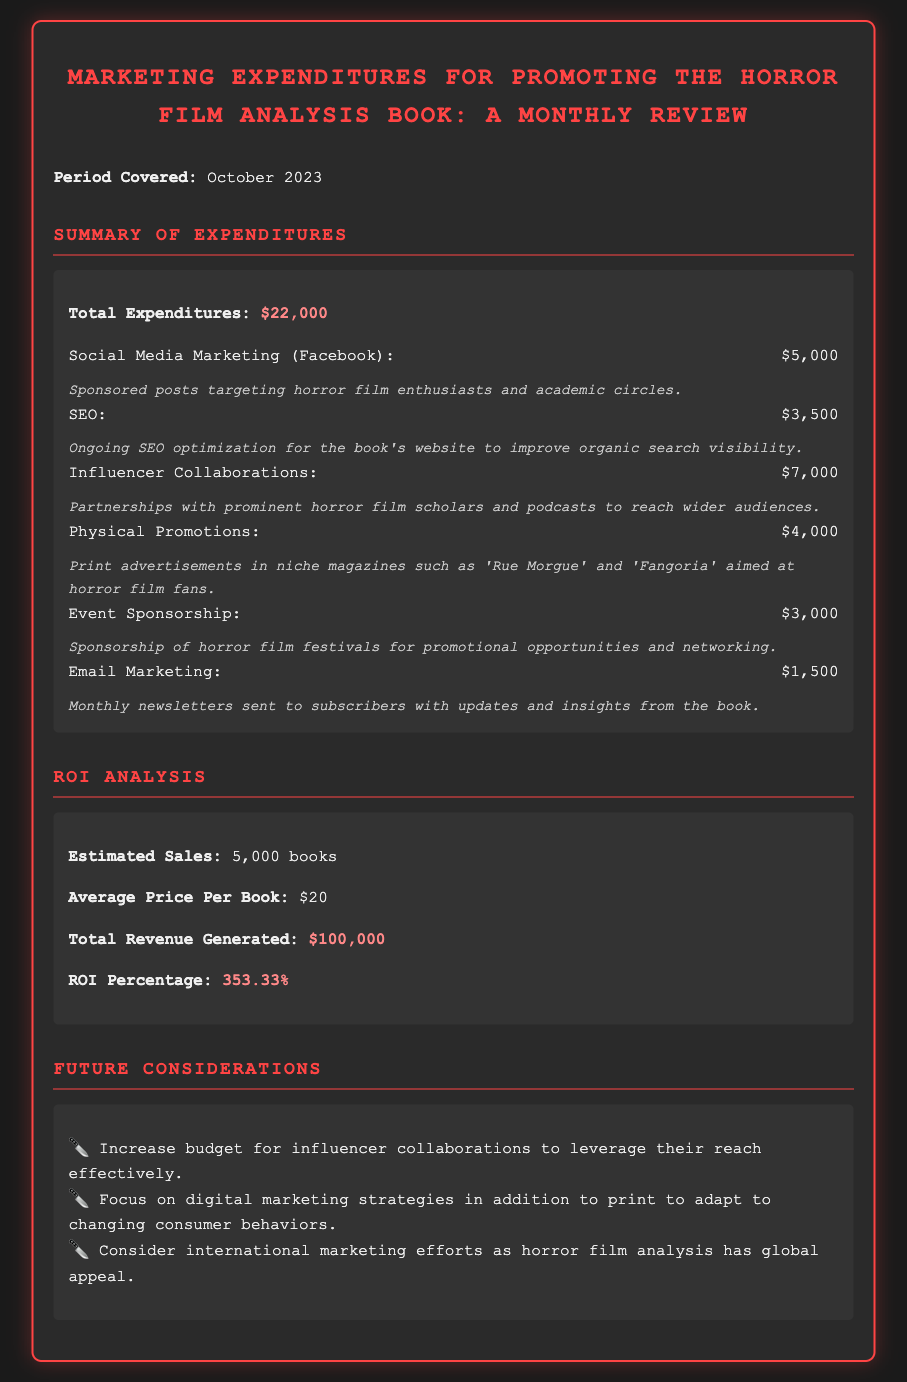What are the total expenditures? The total expenditures are listed in the summary section of the document as $22,000.
Answer: $22,000 How much was spent on Social Media Marketing? The specific amount allocated to Social Media Marketing (Facebook) is clearly stated in the document as part of the expenditures.
Answer: $5,000 What is the estimated number of sales? The estimated sales figure is mentioned in the ROI Analysis section as 5,000 books.
Answer: 5,000 books What is the average price per book? The document specifies the average price per book, which is important for revenue calculations detailed in the ROI Analysis.
Answer: $20 What percentage is the ROI? The document provides the ROI percentage, which is calculated based on total revenue relative to expenditures.
Answer: 353.33% What type of promotions were targeted for horror film fans? The document details the type of physical promotions that were implemented to target the niche audience of horror film fans.
Answer: Print advertisements Which marketing strategy had the highest expenditure? Looking at the expenditure breakdown, the strategy with the highest investment indicates where most resources were allocated.
Answer: Influencer Collaborations What future consideration is suggested regarding digital marketing? The future considerations section discusses adapting to consumer behaviors, emphasizing digital strategies in comparison to print marketing.
Answer: Focus on digital marketing strategies What is the total revenue generated? The total revenue generated from book sales is calculated and presented in the ROI Analysis section of the document.
Answer: $100,000 